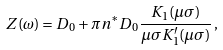Convert formula to latex. <formula><loc_0><loc_0><loc_500><loc_500>Z ( \omega ) & = D _ { 0 } + \pi n ^ { * } D _ { 0 } \frac { K _ { 1 } ( \mu \sigma ) } { \mu \sigma K _ { 1 } ^ { \prime } ( \mu \sigma ) } \, ,</formula> 